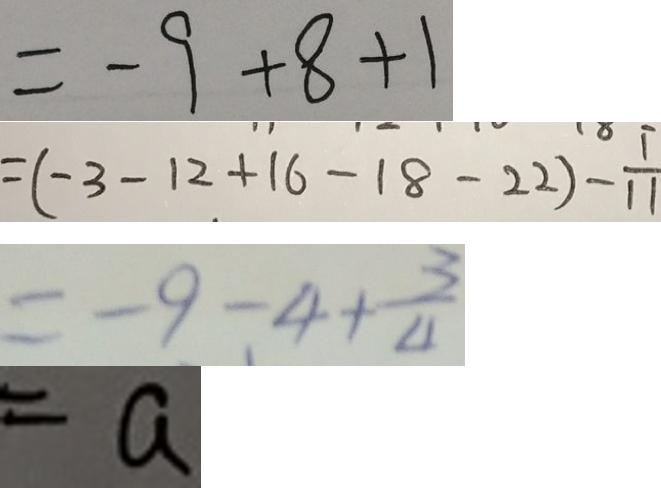<formula> <loc_0><loc_0><loc_500><loc_500>= - 9 + 8 + 1 
 = ( - 3 - 1 2 + 1 6 - 1 8 - 2 2 ) - \frac { 1 } { 1 1 } 
 = - 9 - 4 + \frac { 3 } { 4 } 
 = a</formula> 